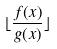Convert formula to latex. <formula><loc_0><loc_0><loc_500><loc_500>\lfloor \frac { f ( x ) } { g ( x ) } \rfloor</formula> 